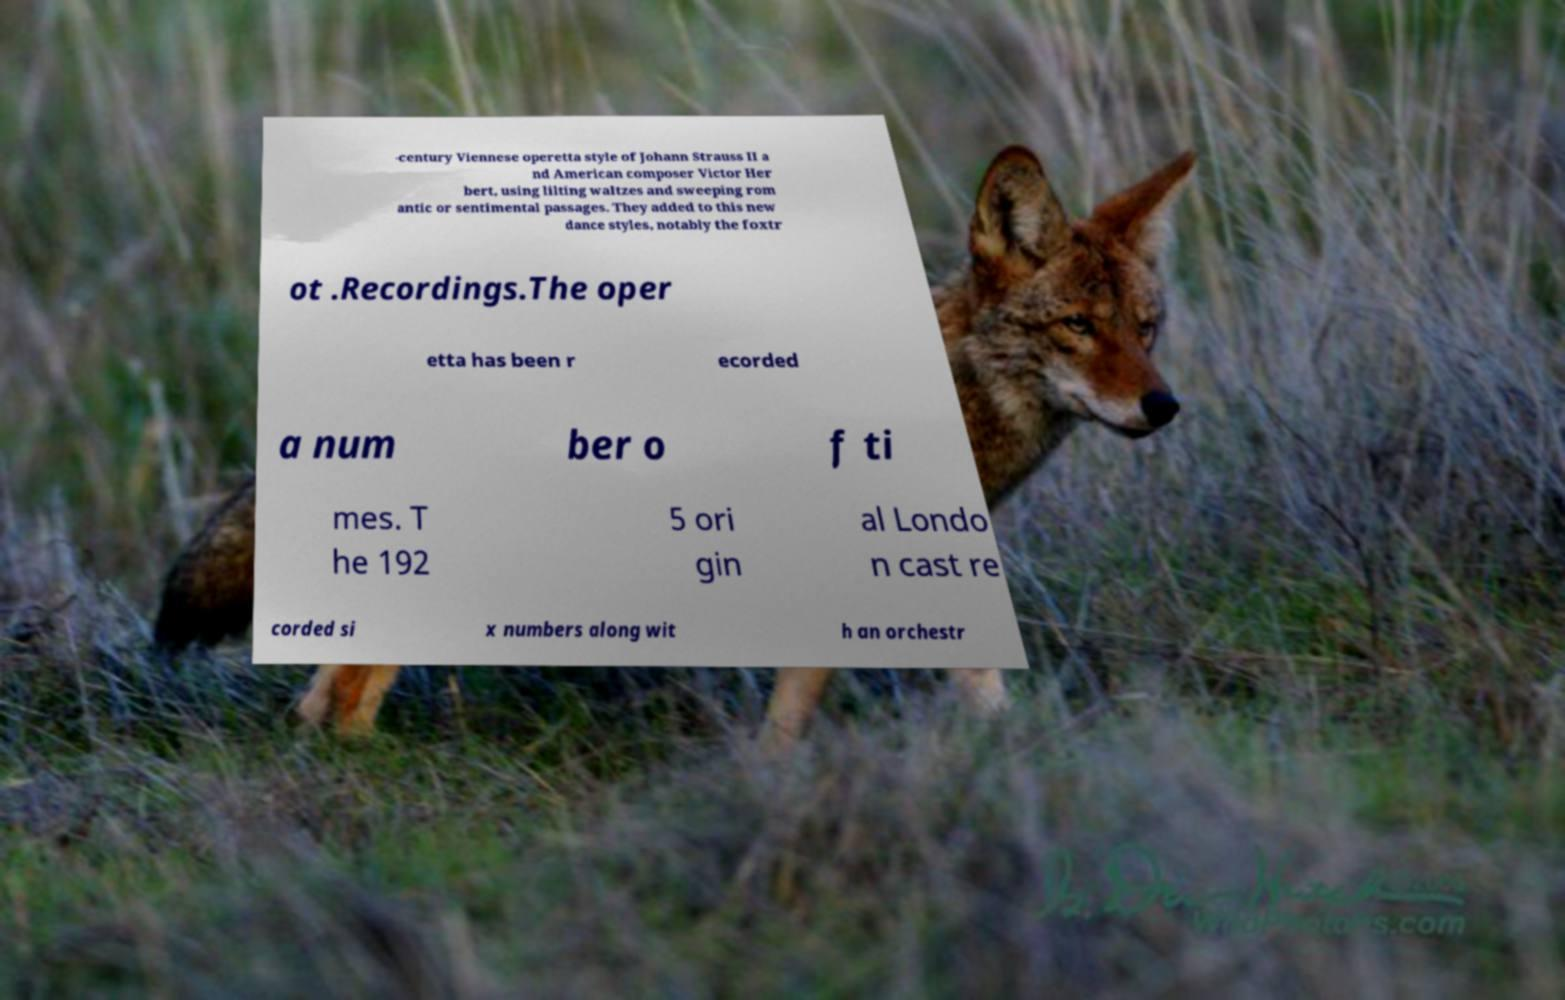There's text embedded in this image that I need extracted. Can you transcribe it verbatim? -century Viennese operetta style of Johann Strauss II a nd American composer Victor Her bert, using lilting waltzes and sweeping rom antic or sentimental passages. They added to this new dance styles, notably the foxtr ot .Recordings.The oper etta has been r ecorded a num ber o f ti mes. T he 192 5 ori gin al Londo n cast re corded si x numbers along wit h an orchestr 